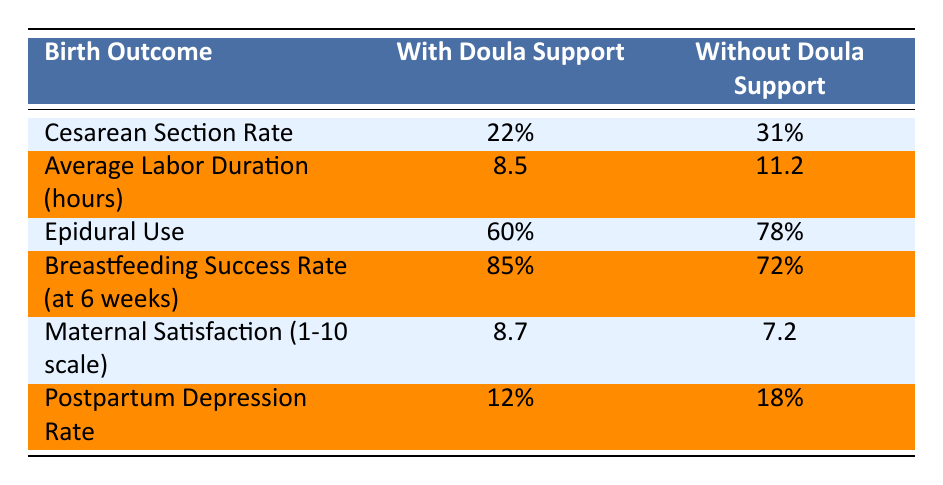What is the Cesarean Section Rate with Doula Support? According to the table, the Cesarean Section Rate with Doula Support is listed as 22%.
Answer: 22% What is the Average Labor Duration for women without Doula Support? From the table, the Average Labor Duration without Doula Support is given as 11.2 hours.
Answer: 11.2 hours Is the Breastfeeding Success Rate higher for those with Doula Support compared to those without? Yes, the Breastfeeding Success Rate with Doula Support is 85%, while it is 72% without Doula Support, indicating a higher success rate with Doula Support.
Answer: Yes What is the difference in Epidural Use between women with and without Doula Support? The Epidural Use is 60% with Doula Support and 78% without. The difference is 78% - 60% = 18%.
Answer: 18% What is the average score of Maternal Satisfaction for both groups combined? To find the average, we add the scores: (8.7 + 7.2) = 15.9 and then divide by 2. The average is 15.9 / 2 = 7.95.
Answer: 7.95 Is the Postpartum Depression Rate lower with Doula Support? Yes, the Postpartum Depression Rate with Doula Support is 12%, compared to 18% without Doula Support, which indicates a lower rate with Doula Support.
Answer: Yes What percentage of women used Epidurals when they had Doula Support? The table shows that 60% of women used Epidurals with Doula Support.
Answer: 60% What is the overall trend regarding Maternal Satisfaction between the two groups? The table indicates that Maternal Satisfaction is higher for those with Doula Support (8.7) compared to those without (7.2), suggesting that better support leads to higher satisfaction.
Answer: Higher satisfaction with Doula Support What is the average increase in success rates for Breastfeeding with Doula Support? The Breastfeeding Success Rate is 85% with Doula Support and 72% without. The increase is 85% - 72% = 13%.
Answer: 13% 